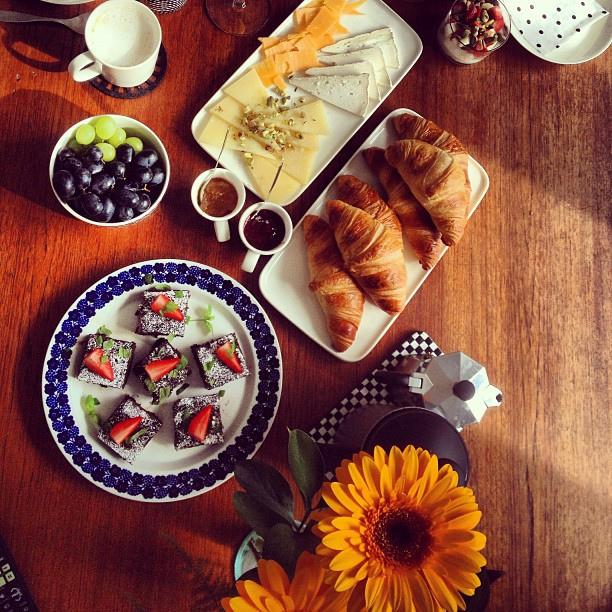Are there flowers on the table?
Short answer required. Yes. How good would this food taste?
Short answer required. Very good. How many pastry are on the table?
Answer briefly. 6. 